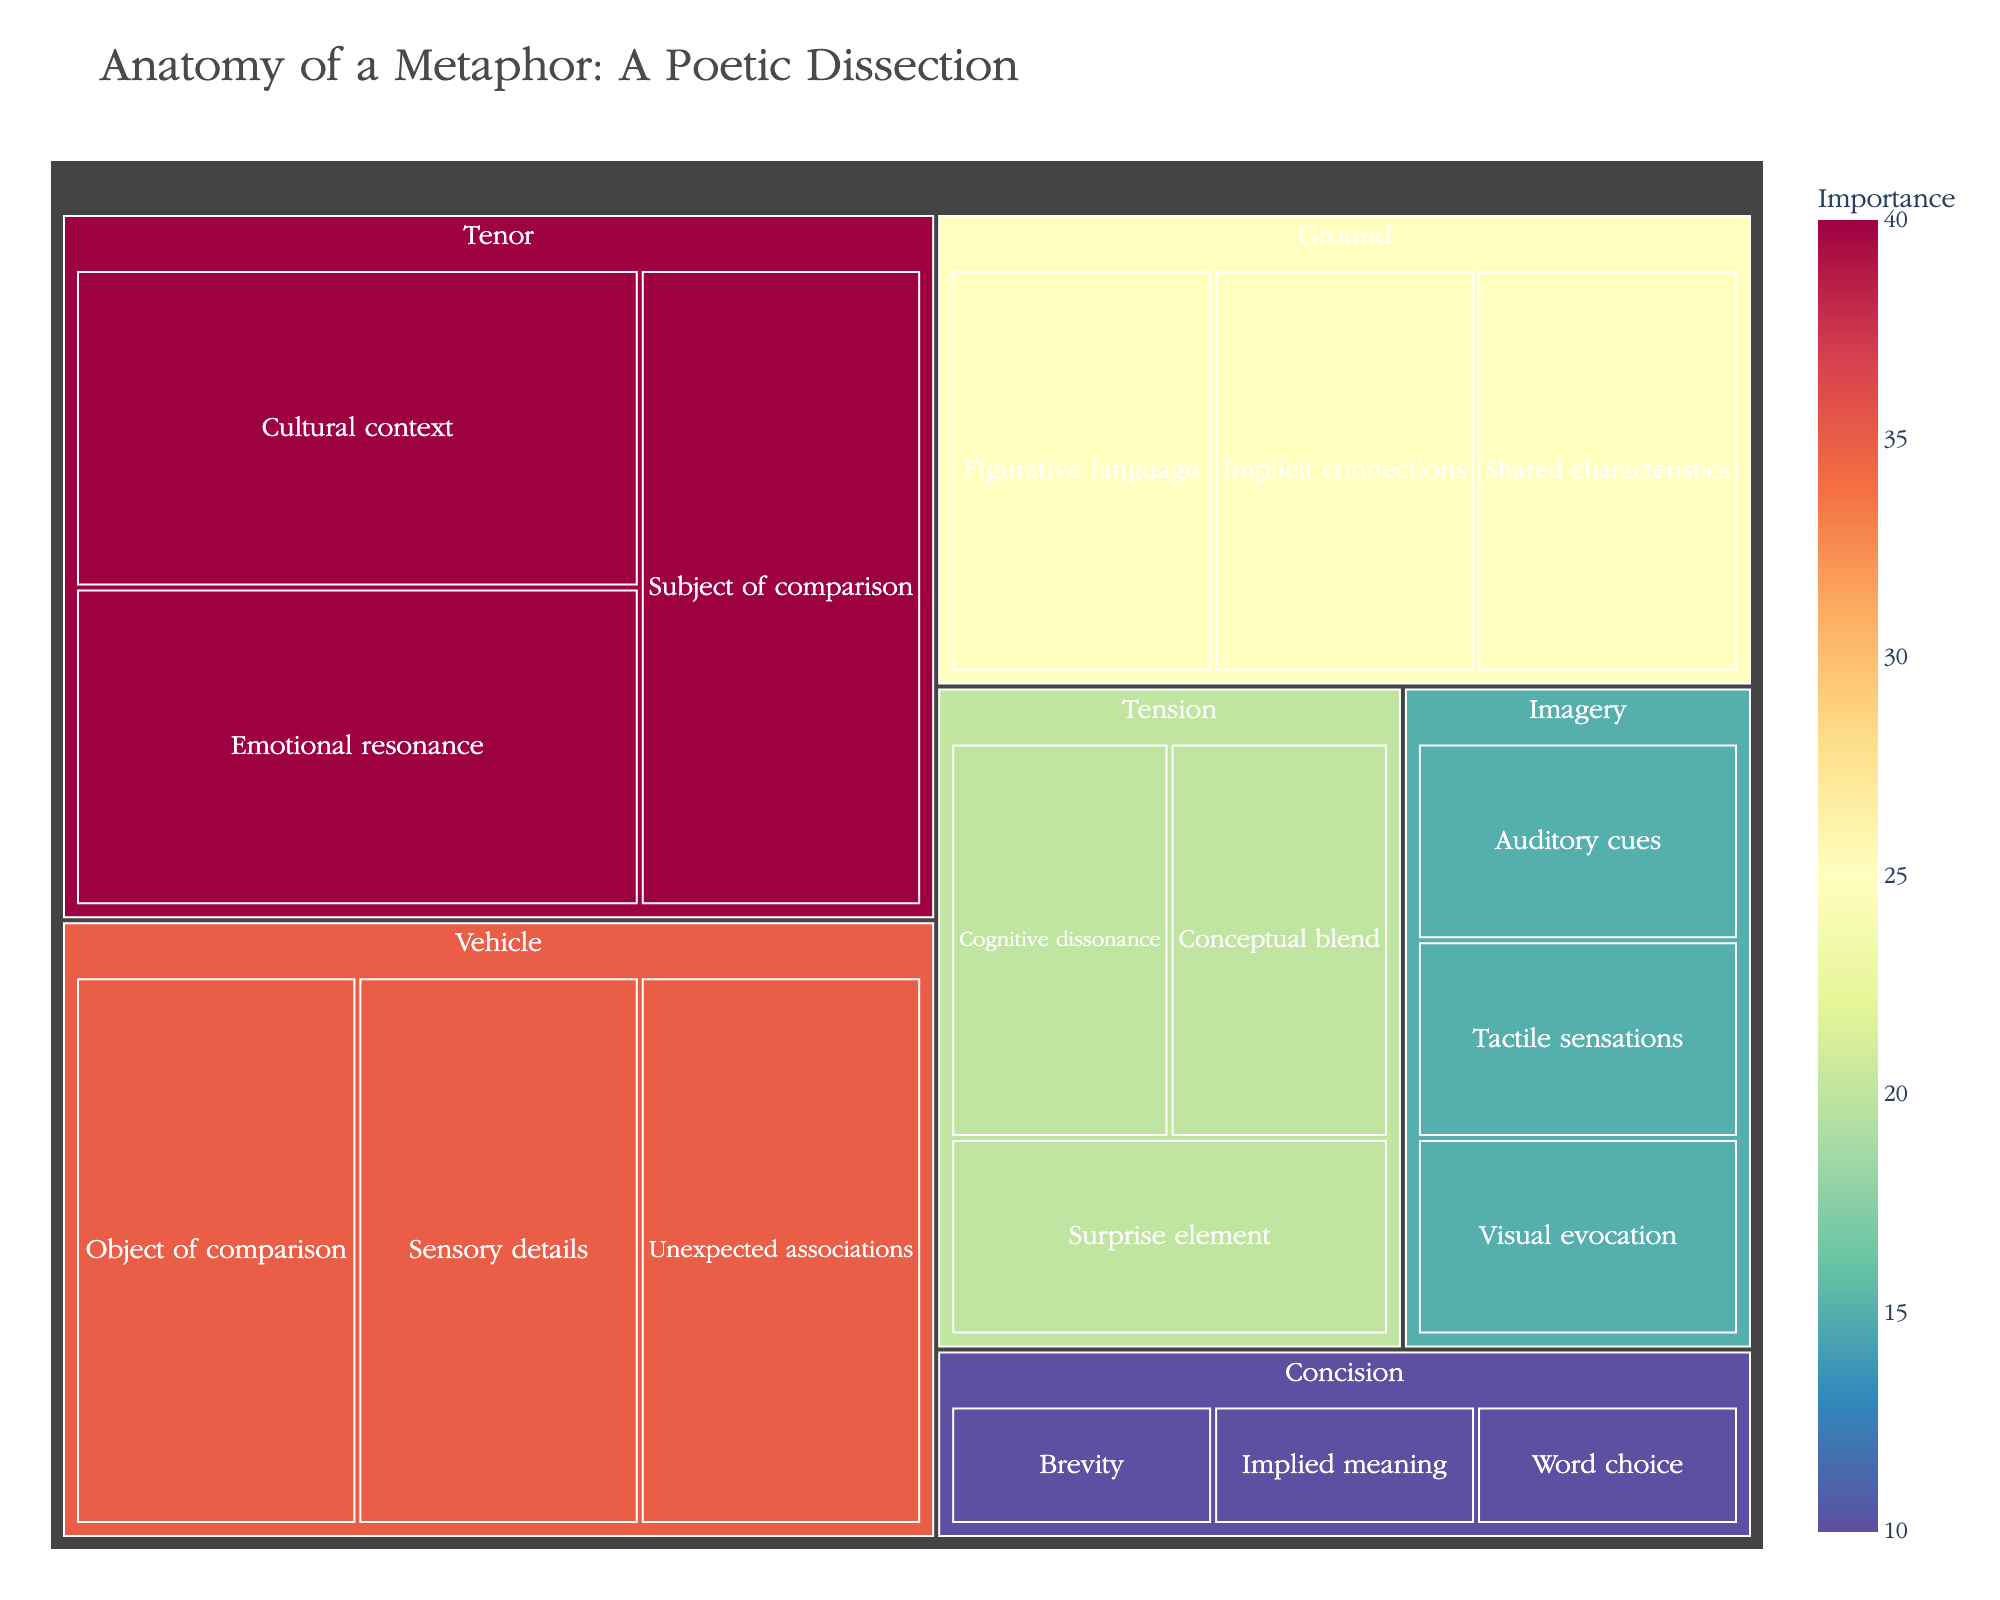What is the title of the treemap? The title is usually the most prominent text at the top of the figure. It summarizes what the figure is about to give the viewer immediate context.
Answer: Anatomy of a Metaphor: A Poetic Dissection Which component has the highest importance value? Look for the component with the largest area or the highest numerical value representing importance.
Answer: Tenor How many subcomponents does the "Vehicle" component have? Count the number of labeled areas within the "Vehicle" section of the treemap.
Answer: 3 What is the combined importance of the subcomponents of "Tension"? Sum the importance values of all subcomponents under the "Tension" component. That would be Cognitive dissonance (20), Surprise element (20), and Conceptual blend (20), resulting in 60.
Answer: 60 Which component has the smallest collective importance value? Compare the sum of the importance values of subcomponents for each major component. "Concision" has the smallest collective importance (30).
Answer: Concision Which subcomponent within "Imagery" has a higher importance: "Visual evocation" or "Auditory cues"? Compare the importance values of the two subcomponents within the "Imagery" component.
Answer: They have equal importance What is the total importance of all the subcomponents under "Tenor"? Add the importance values for all the subcomponents under "Tenor": Subject of comparison (40), Emotional resonance (40), and Cultural context (40). The total is 120.
Answer: 120 Which has greater importance: "Sensory details" (a subcomponent under "Vehicle") or "Implicit connections" (a subcomponent under "Ground")? Compare the importance values of "Sensory details" and "Implicit connections." Both have the same value of 25.
Answer: Equal importance Which subcomponent has the highest importance in the "Ground" component? Identify the subcomponent under "Ground" with the largest importance value. All subcomponents in "Ground" have a value of 25, so they are equal.
Answer: All are equal What is the difference in importance between the "Visual evocation" subcomponent of "Imagery" and the "Surprise element" subcomponent of "Tension"? Subtract the importance value of "Visual evocation" from "Surprise element." Both have the same importance value of 20, so the difference is 0.
Answer: 0 